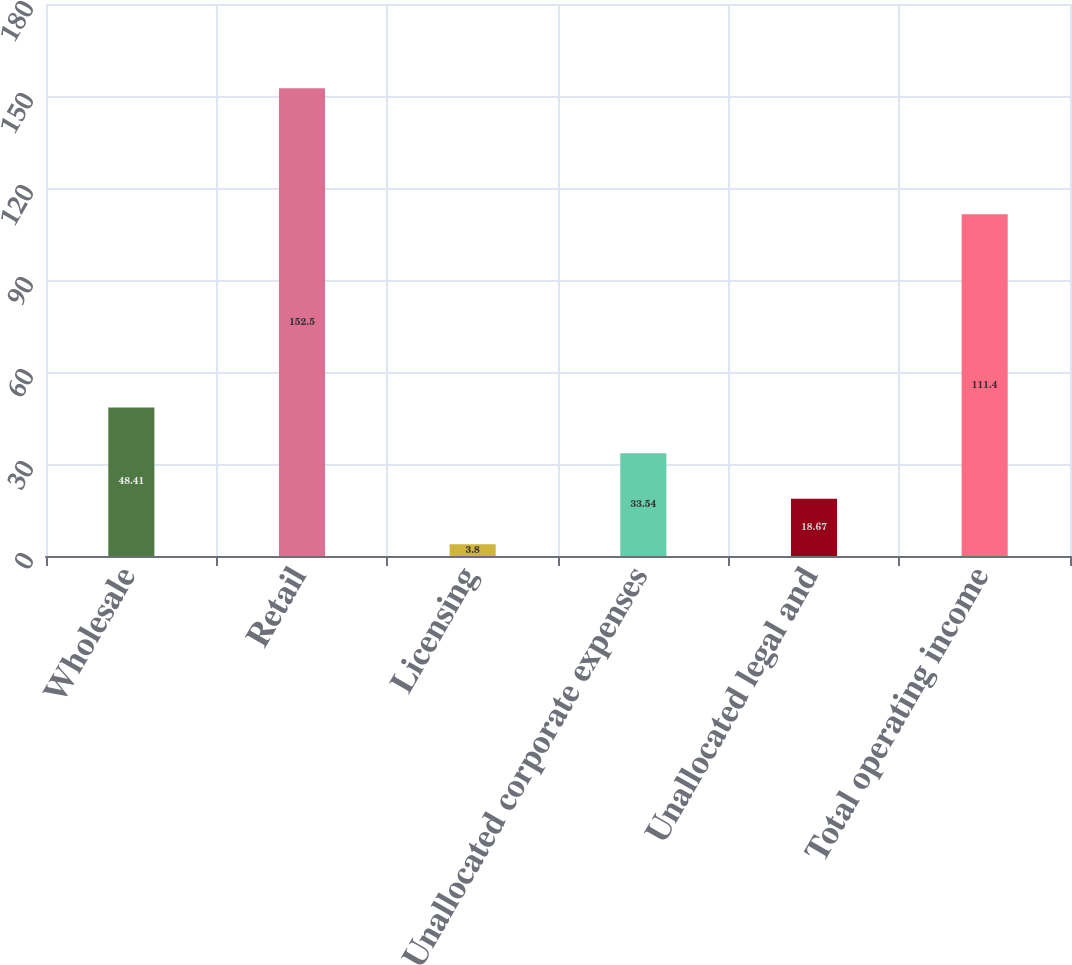<chart> <loc_0><loc_0><loc_500><loc_500><bar_chart><fcel>Wholesale<fcel>Retail<fcel>Licensing<fcel>Unallocated corporate expenses<fcel>Unallocated legal and<fcel>Total operating income<nl><fcel>48.41<fcel>152.5<fcel>3.8<fcel>33.54<fcel>18.67<fcel>111.4<nl></chart> 